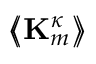Convert formula to latex. <formula><loc_0><loc_0><loc_500><loc_500>\left \langle \, \left \langle K _ { m } ^ { \kappa } \right \rangle \, \right \rangle</formula> 